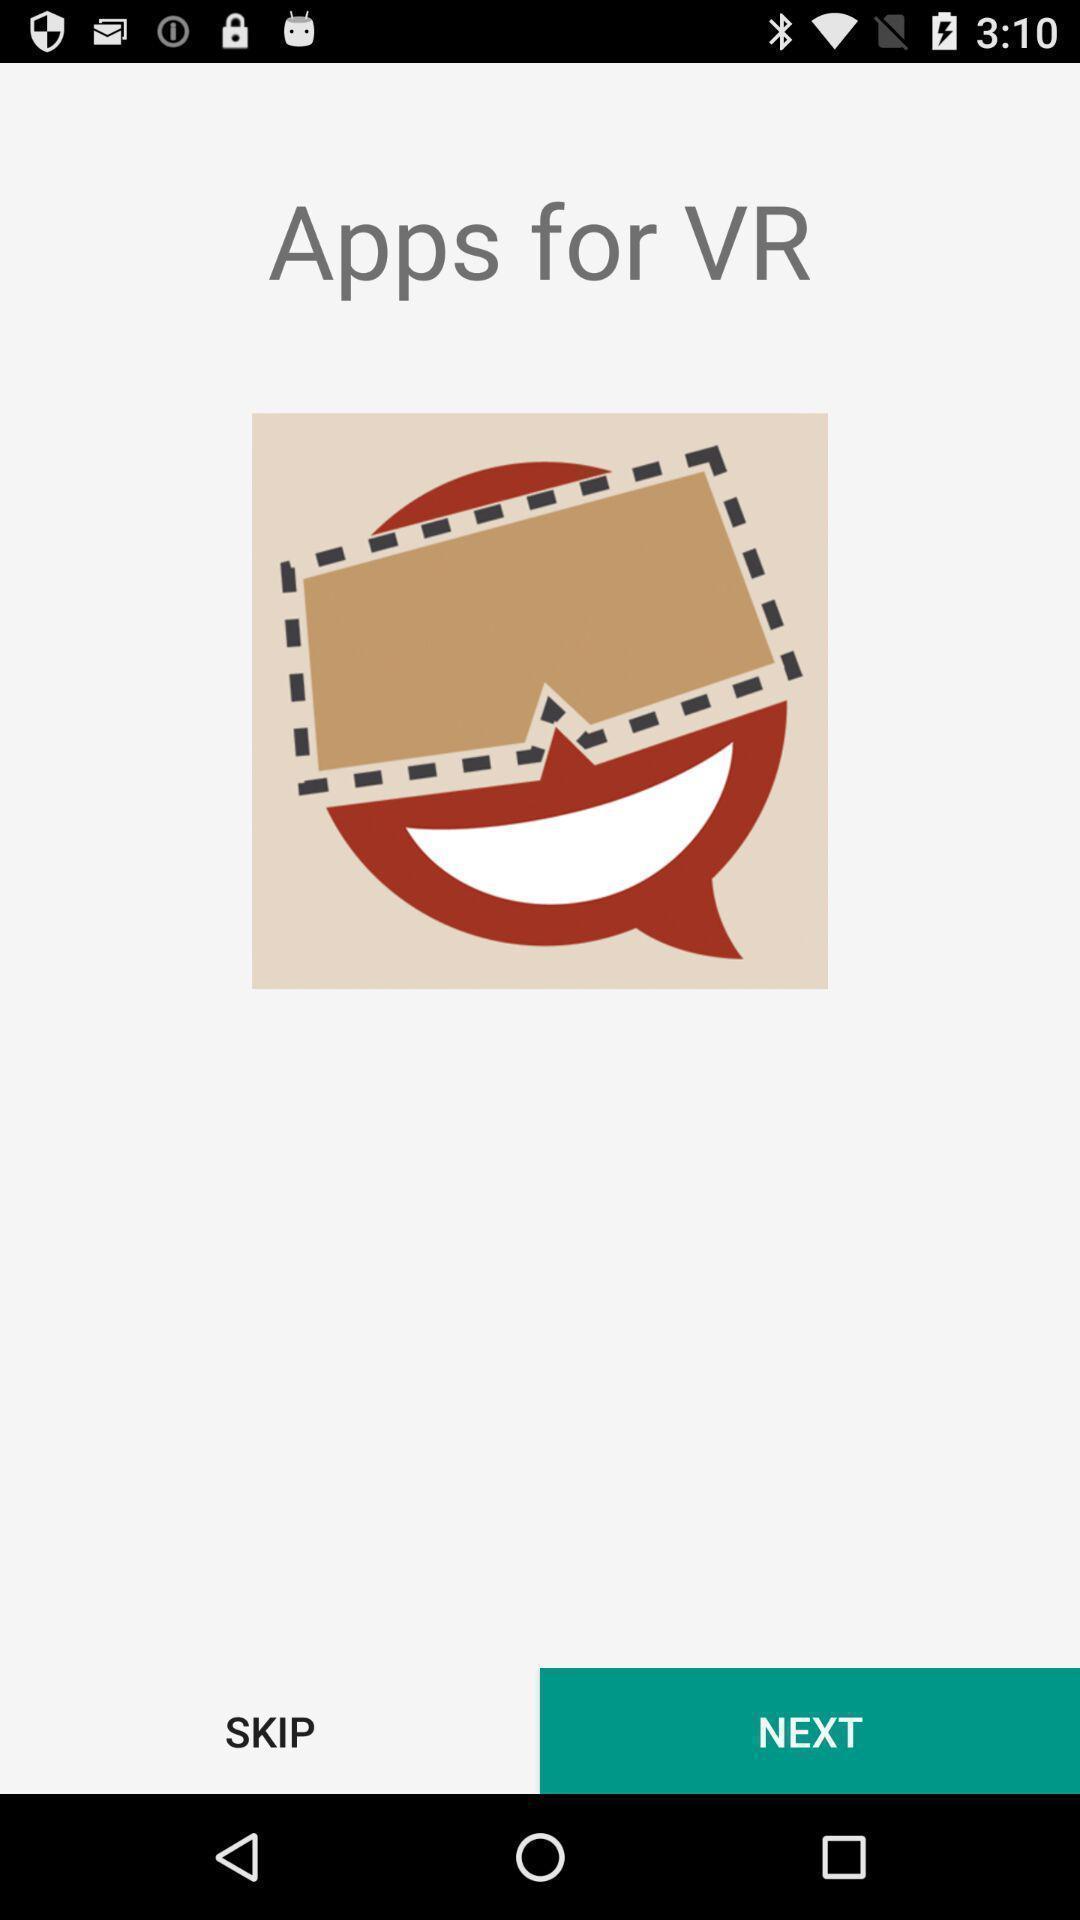Provide a description of this screenshot. Welcome page. 